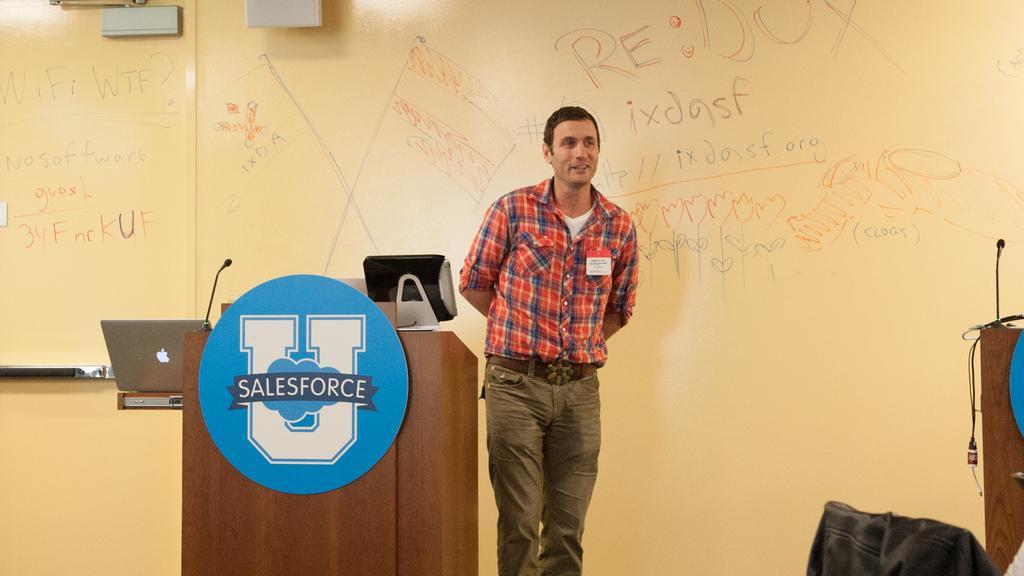How would you summarize this image in a sentence or two? In this image I can see a person standing on the stage beside the table, also there is a wall at the back with some letters. 